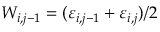<formula> <loc_0><loc_0><loc_500><loc_500>W _ { i , j - 1 } = ( \varepsilon _ { i , j - 1 } + \varepsilon _ { i , j } ) / 2</formula> 